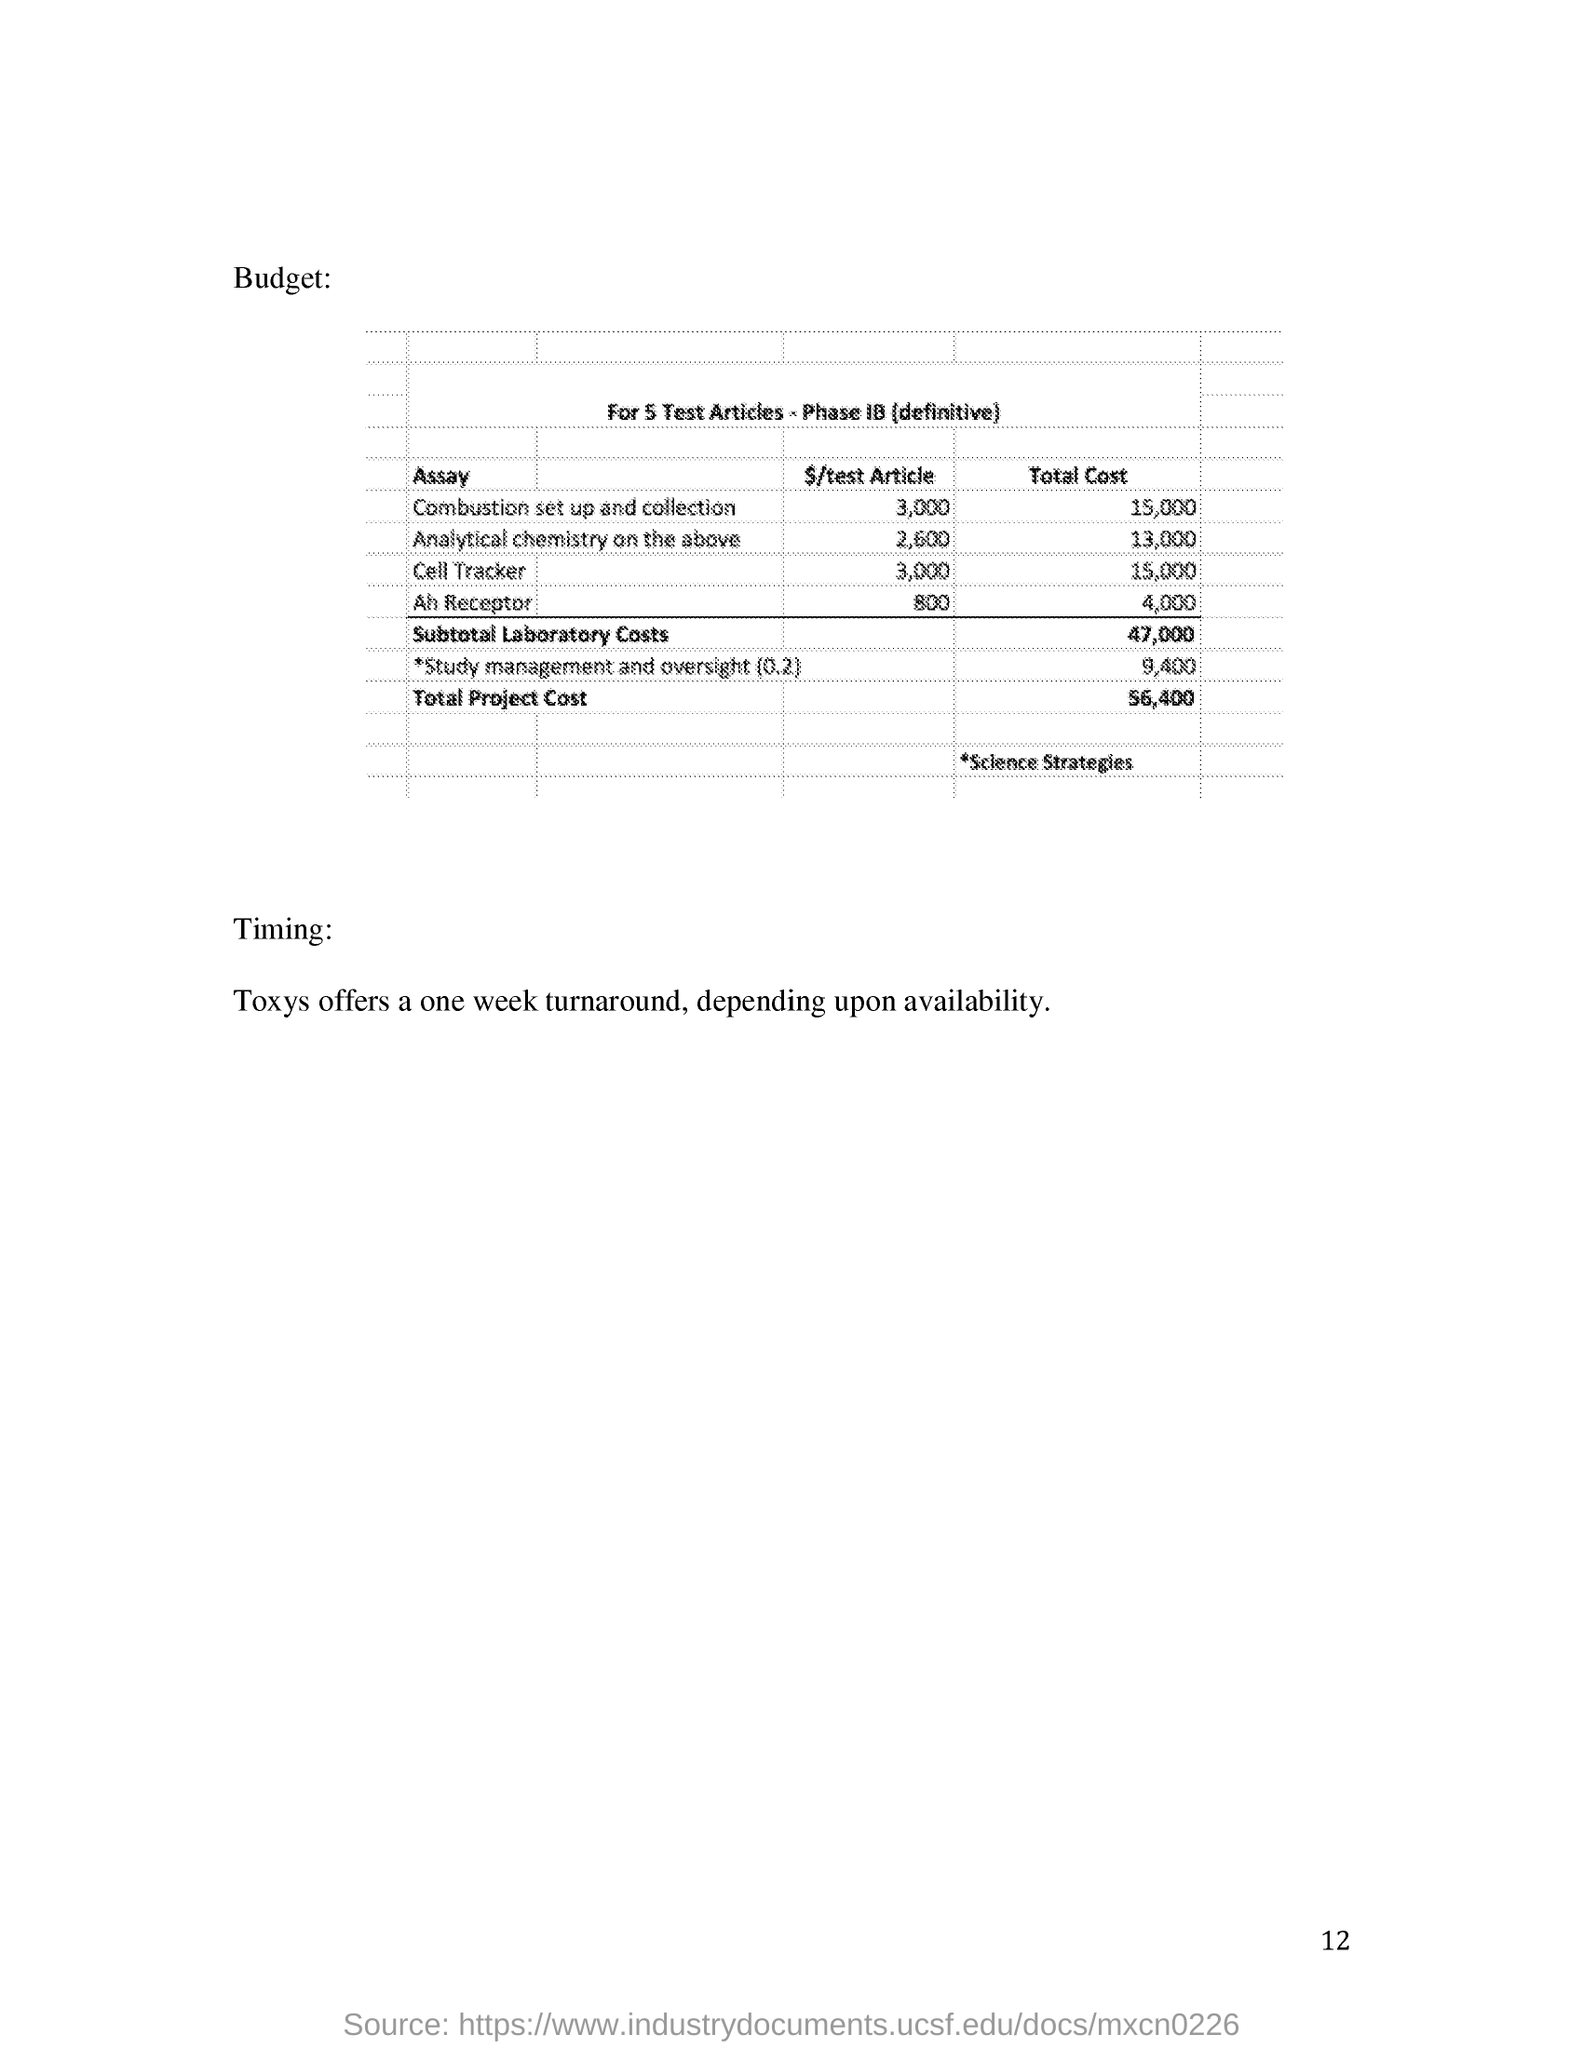What is the timing mentioned?
Your response must be concise. Toxys offers a one week turnaround, depending upon availability. What is the Total Project Cost?
Provide a succinct answer. 56,400. What is the heading of the budget table?
Offer a very short reply. For 5 Test Articles - Phase IB (definitive). 